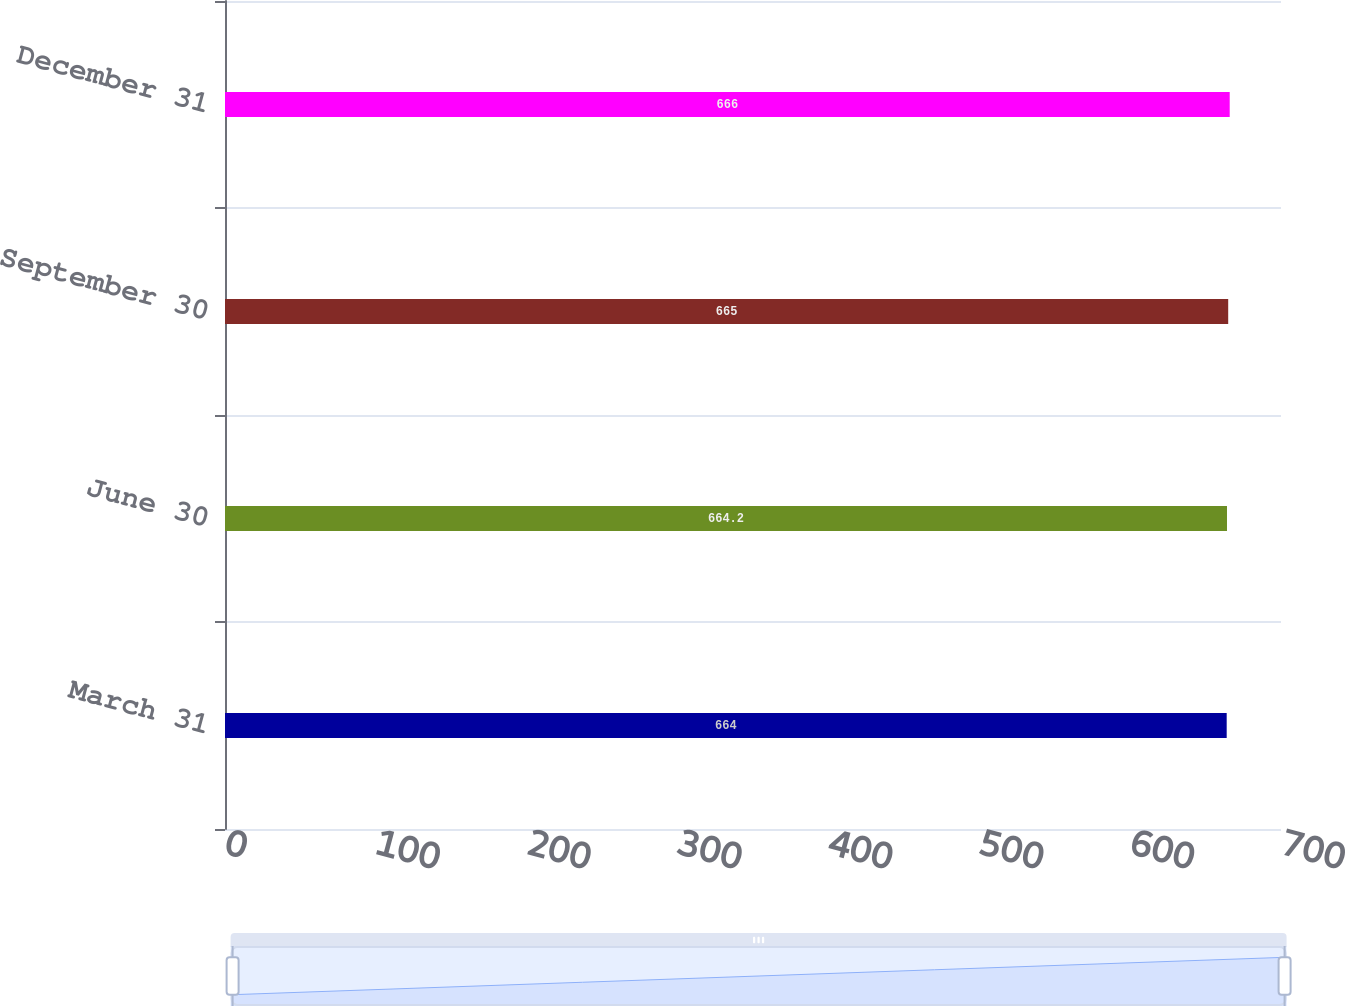<chart> <loc_0><loc_0><loc_500><loc_500><bar_chart><fcel>March 31<fcel>June 30<fcel>September 30<fcel>December 31<nl><fcel>664<fcel>664.2<fcel>665<fcel>666<nl></chart> 